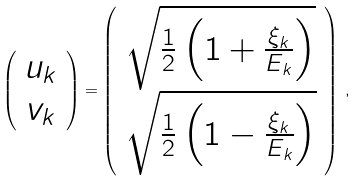<formula> <loc_0><loc_0><loc_500><loc_500>\left ( \begin{array} { c } u _ { k } \\ v _ { k } \end{array} \right ) = \left ( \begin{array} { c } \sqrt { \frac { 1 } { 2 } \left ( 1 + \frac { \xi _ { k } } { E _ { k } } \right ) } \\ \sqrt { \frac { 1 } { 2 } \left ( 1 - \frac { \xi _ { k } } { E _ { k } } \right ) } \end{array} \right ) \, ,</formula> 